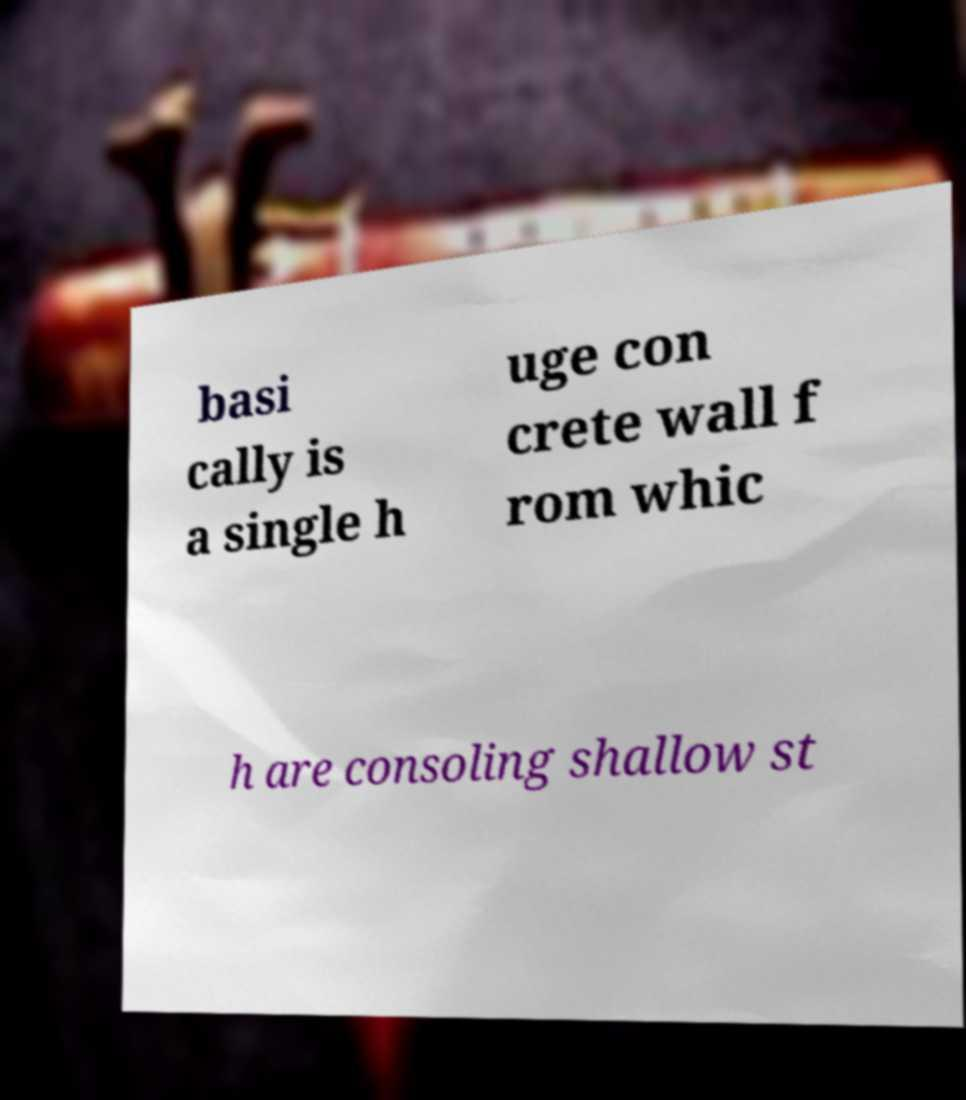Could you extract and type out the text from this image? basi cally is a single h uge con crete wall f rom whic h are consoling shallow st 